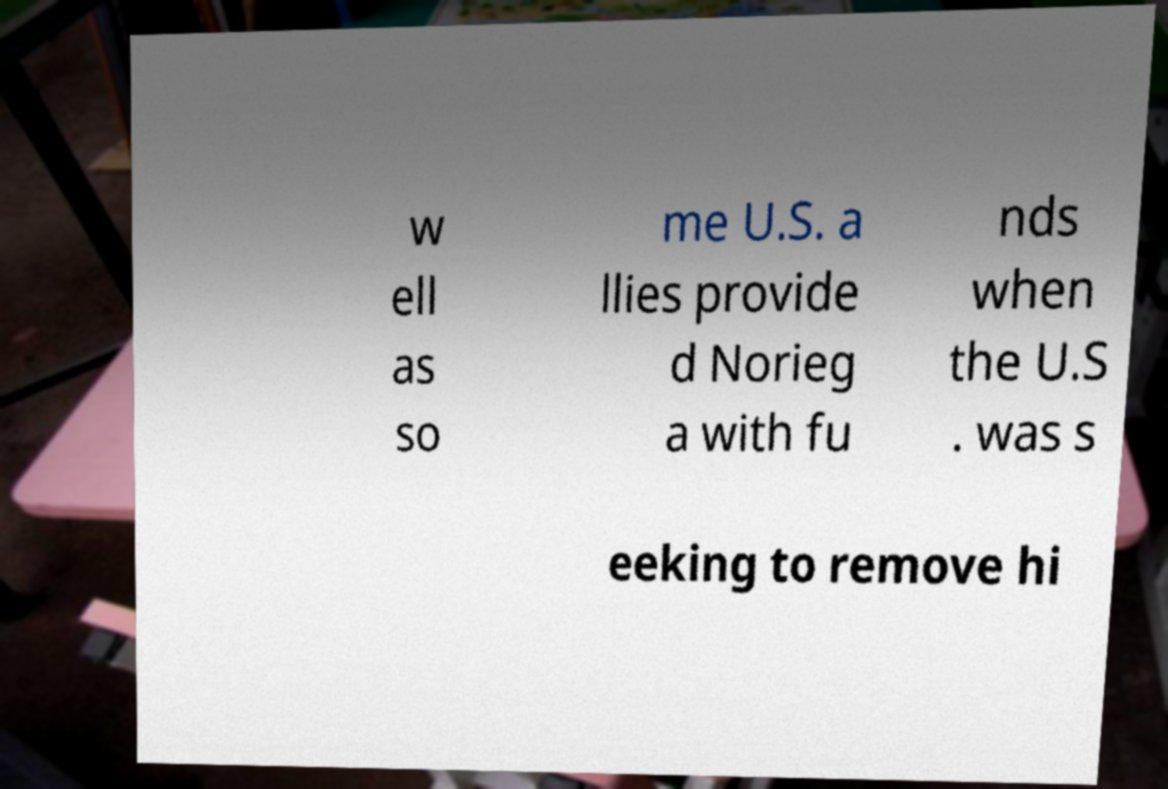Can you accurately transcribe the text from the provided image for me? w ell as so me U.S. a llies provide d Norieg a with fu nds when the U.S . was s eeking to remove hi 